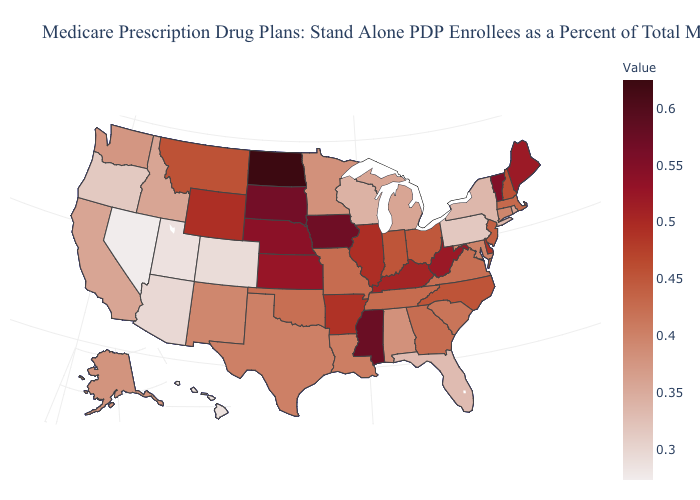Does Minnesota have a lower value than Oregon?
Short answer required. No. Among the states that border Texas , which have the lowest value?
Quick response, please. New Mexico. Does Nevada have the lowest value in the USA?
Short answer required. Yes. Does Wyoming have the highest value in the West?
Give a very brief answer. Yes. Does New York have the highest value in the Northeast?
Answer briefly. No. Among the states that border Missouri , does Oklahoma have the lowest value?
Keep it brief. Yes. Among the states that border Maine , which have the highest value?
Concise answer only. New Hampshire. Does Minnesota have the highest value in the USA?
Be succinct. No. 